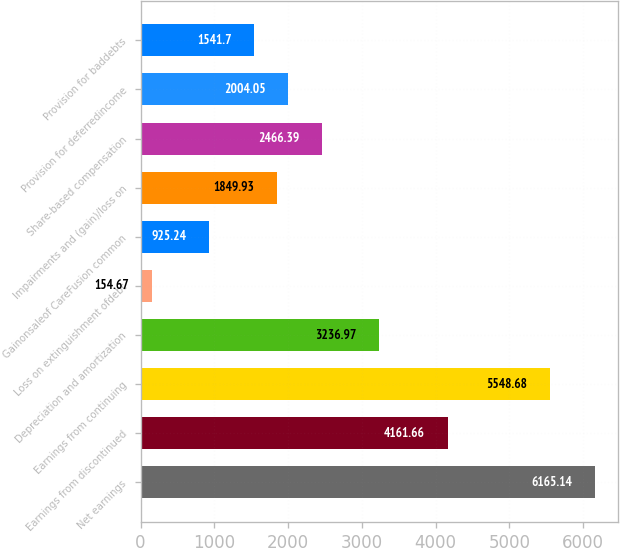Convert chart. <chart><loc_0><loc_0><loc_500><loc_500><bar_chart><fcel>Net earnings<fcel>Earnings from discontinued<fcel>Earnings from continuing<fcel>Depreciation and amortization<fcel>Loss on extinguishment ofdebt<fcel>Gainonsaleof CareFusion common<fcel>Impairments and (gain)/loss on<fcel>Share-based compensation<fcel>Provision for deferredincome<fcel>Provision for baddebts<nl><fcel>6165.14<fcel>4161.66<fcel>5548.68<fcel>3236.97<fcel>154.67<fcel>925.24<fcel>1849.93<fcel>2466.39<fcel>2004.05<fcel>1541.7<nl></chart> 